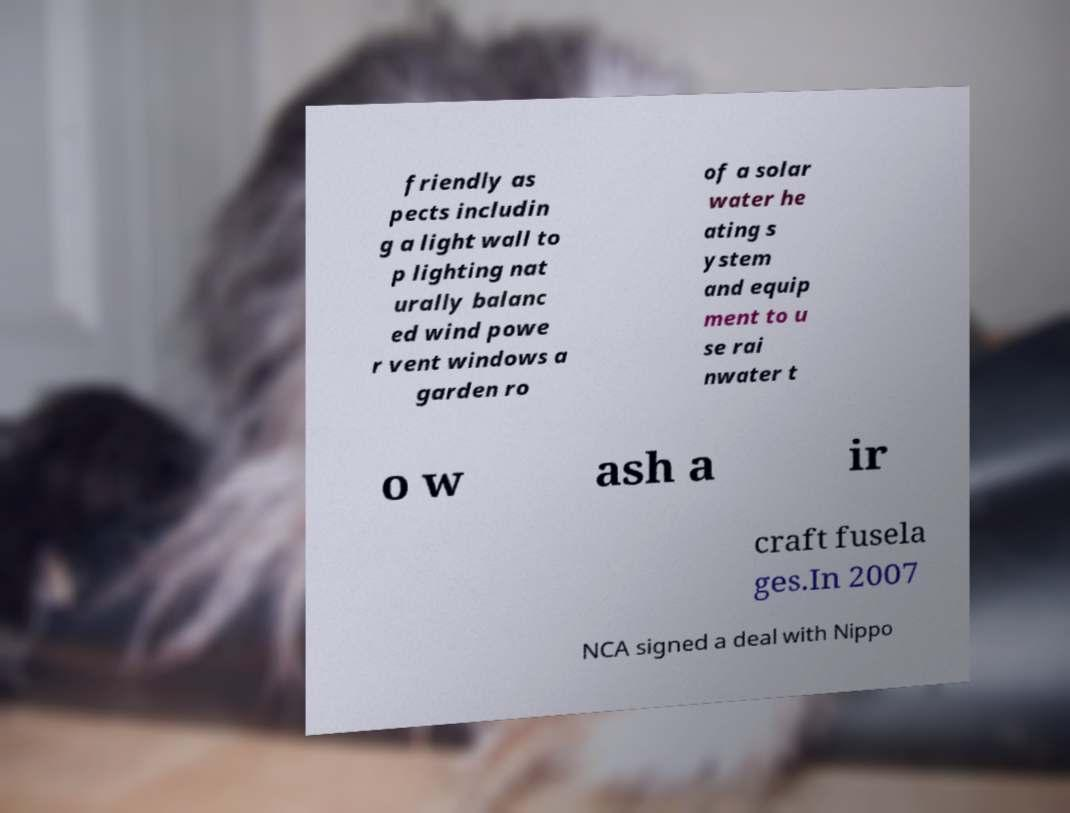Could you assist in decoding the text presented in this image and type it out clearly? friendly as pects includin g a light wall to p lighting nat urally balanc ed wind powe r vent windows a garden ro of a solar water he ating s ystem and equip ment to u se rai nwater t o w ash a ir craft fusela ges.In 2007 NCA signed a deal with Nippo 